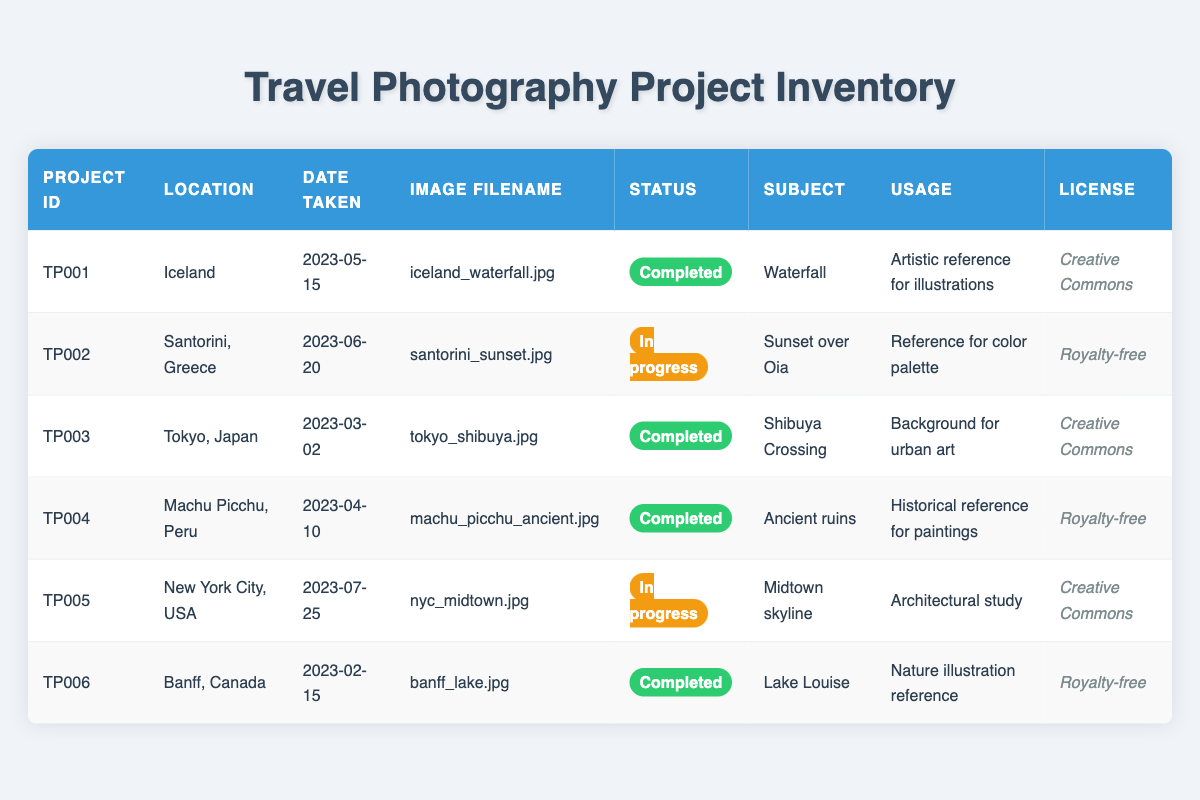What is the status of the project taken in Santorini, Greece? The project taken in Santorini, Greece is identified by the project ID TP002. When looking at the status column for this project, it indicates "In progress".
Answer: In progress How many projects are marked as completed? By observing the status column, there are three projects with the status "Completed", which are TP001, TP003, TP004, and TP006. This can be counted directly from the table entries that match this status.
Answer: Four Which project was taken on 2023-03-02? To find the project taken on this date, locate the date in the table. The entry for Tokyo, Japan with project ID TP003 corresponds to this date.
Answer: TP003 What is the subject of the completed project with the image filename "banff_lake.jpg"? The filename "banff_lake.jpg" is associated with project ID TP006, which is completed. The subject for this project is listed as "Lake Louise".
Answer: Lake Louise Are there any projects that have a "Royalty-free" license with a status of "In progress"? Reviewing the table, there are no entries that combine a "Royalty-free" license with a status of "In progress". Thus, the answer is determined by checking each row for both conditions.
Answer: No What is the total number of unique locations represented in the projects? To find the unique locations, we list all the distinct locations from the table: Iceland, Santorini, Tokyo, Machu Picchu, New York City, and Banff. Counting them gives us six unique locations.
Answer: Six Which project has the latest date taken? By looking at the date taken for all projects, the latest date corresponds to the project TP005 in New York City on 2023-07-25. This is the latest when compared to the other dates.
Answer: TP005 What type of usage is associated with the project about ancient ruins? The project about ancient ruins is identified as TP004, which indicates the usage is "Historical reference for paintings". This is retrieved from the relevant row in the table.
Answer: Historical reference for paintings 